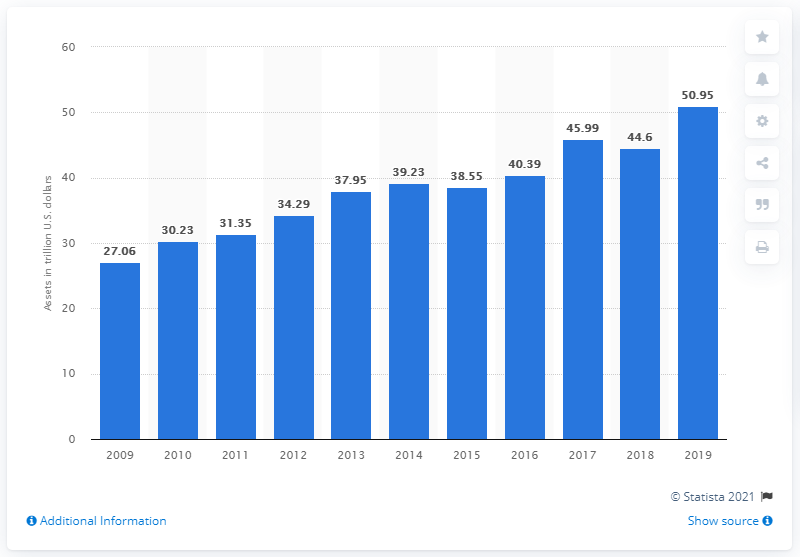Point out several critical features in this image. As of 2009, the value of pension funds in the United States was approximately 27.06 trillion US dollars. 